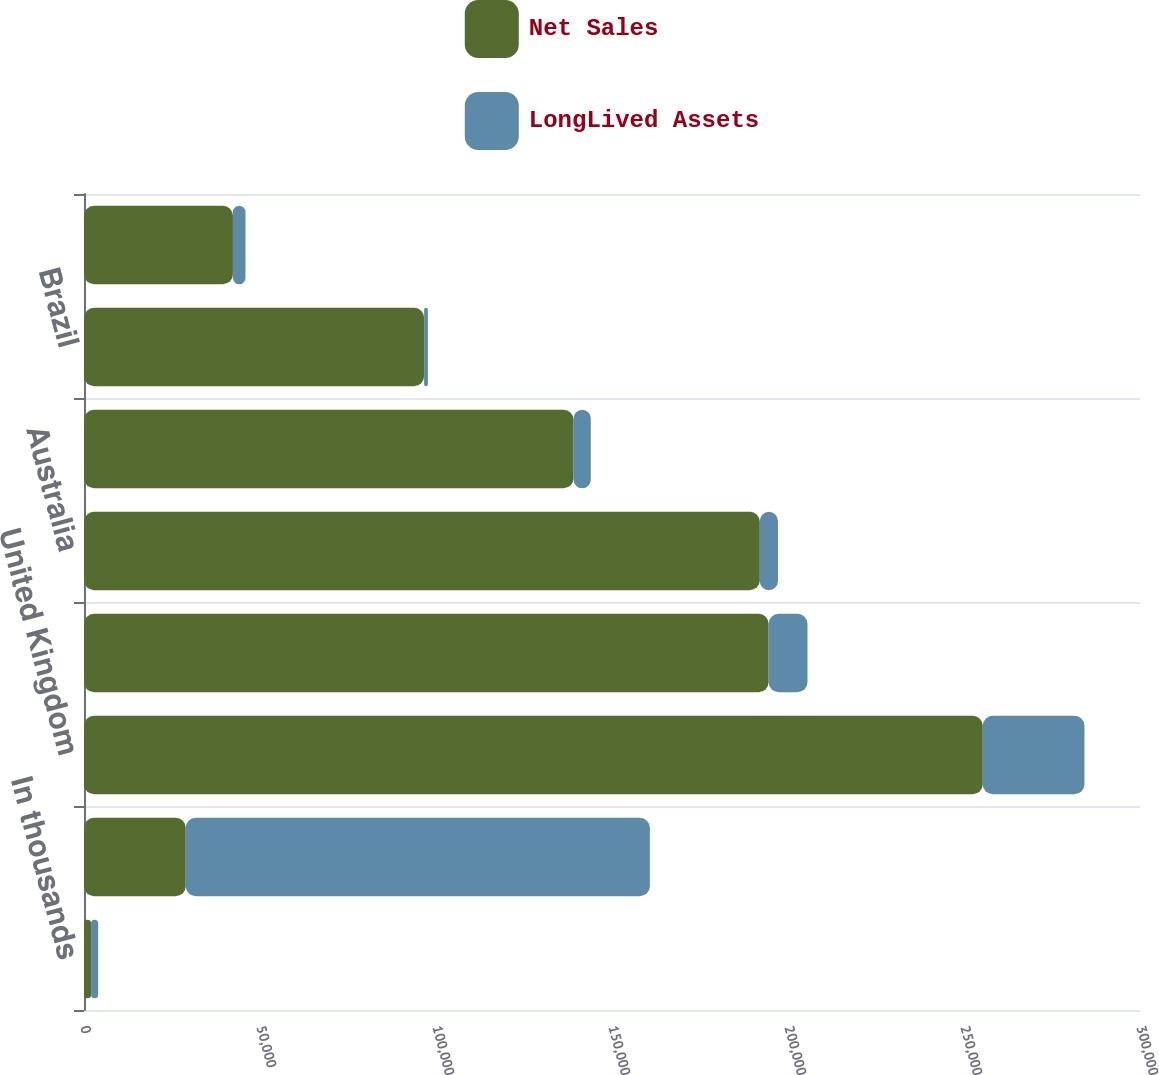Convert chart to OTSL. <chart><loc_0><loc_0><loc_500><loc_500><stacked_bar_chart><ecel><fcel>In thousands<fcel>United States<fcel>United Kingdom<fcel>Canada<fcel>Australia<fcel>Mexico<fcel>Brazil<fcel>France<nl><fcel>Net Sales<fcel>2012<fcel>28905<fcel>255326<fcel>194493<fcel>191994<fcel>139089<fcel>96620<fcel>42310<nl><fcel>LongLived Assets<fcel>2012<fcel>131850<fcel>28905<fcel>11043<fcel>5151<fcel>4886<fcel>1082<fcel>3564<nl></chart> 